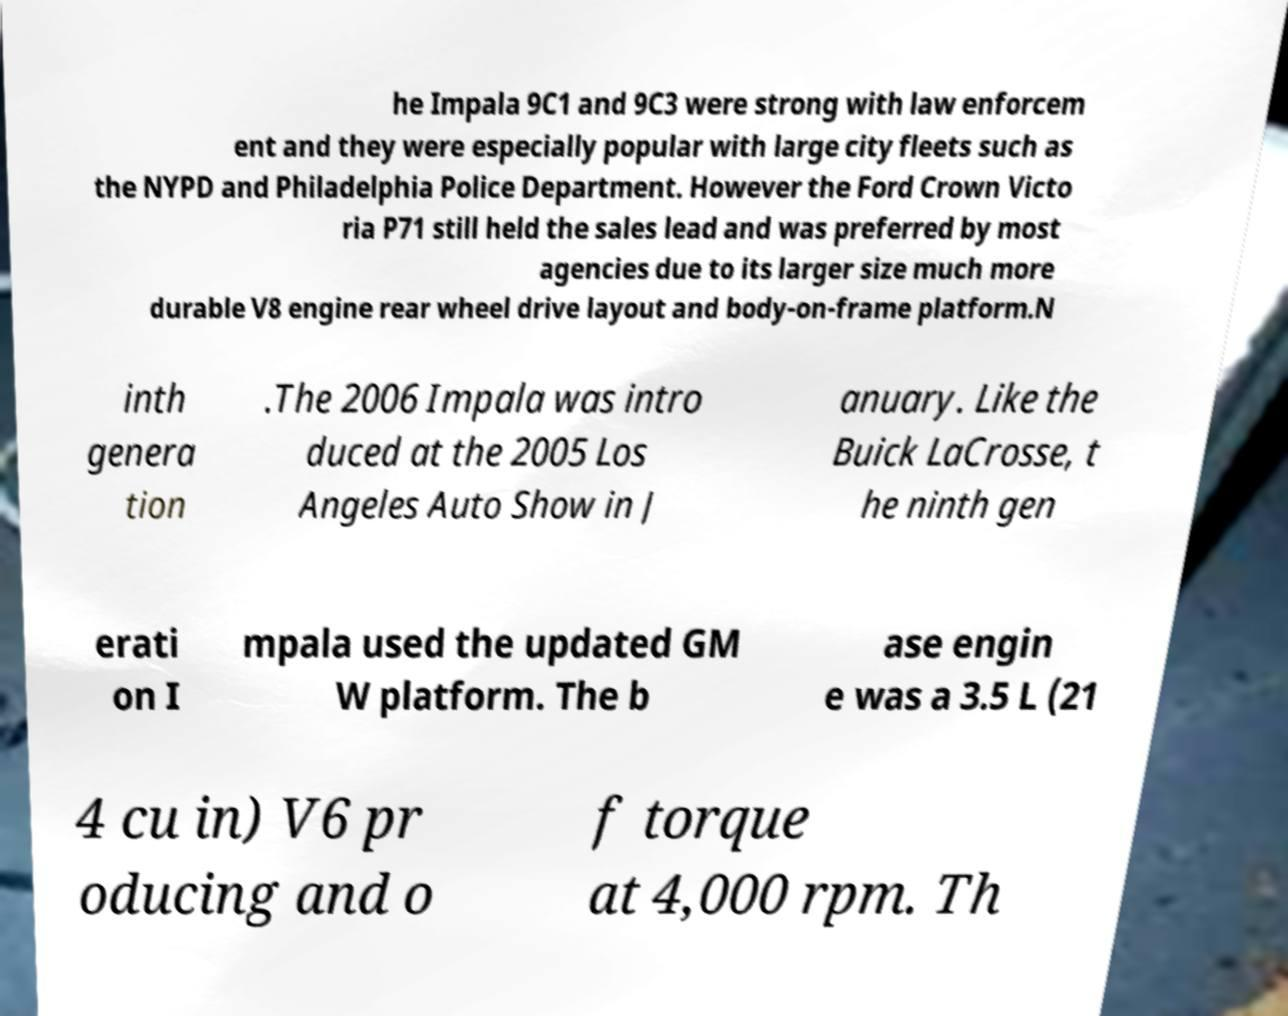There's text embedded in this image that I need extracted. Can you transcribe it verbatim? he Impala 9C1 and 9C3 were strong with law enforcem ent and they were especially popular with large city fleets such as the NYPD and Philadelphia Police Department. However the Ford Crown Victo ria P71 still held the sales lead and was preferred by most agencies due to its larger size much more durable V8 engine rear wheel drive layout and body-on-frame platform.N inth genera tion .The 2006 Impala was intro duced at the 2005 Los Angeles Auto Show in J anuary. Like the Buick LaCrosse, t he ninth gen erati on I mpala used the updated GM W platform. The b ase engin e was a 3.5 L (21 4 cu in) V6 pr oducing and o f torque at 4,000 rpm. Th 